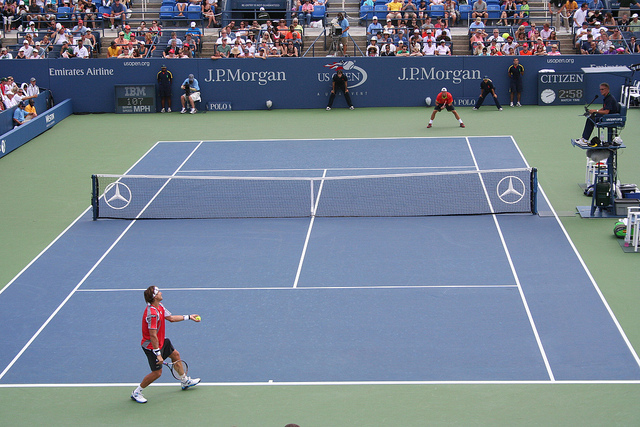Identify and read out the text in this image. J.P P.Morgan US POLO .Morgan 2:58 CITIZEN J.P. MPH IBM Airline Emirates 